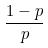<formula> <loc_0><loc_0><loc_500><loc_500>\frac { 1 - p } { p }</formula> 